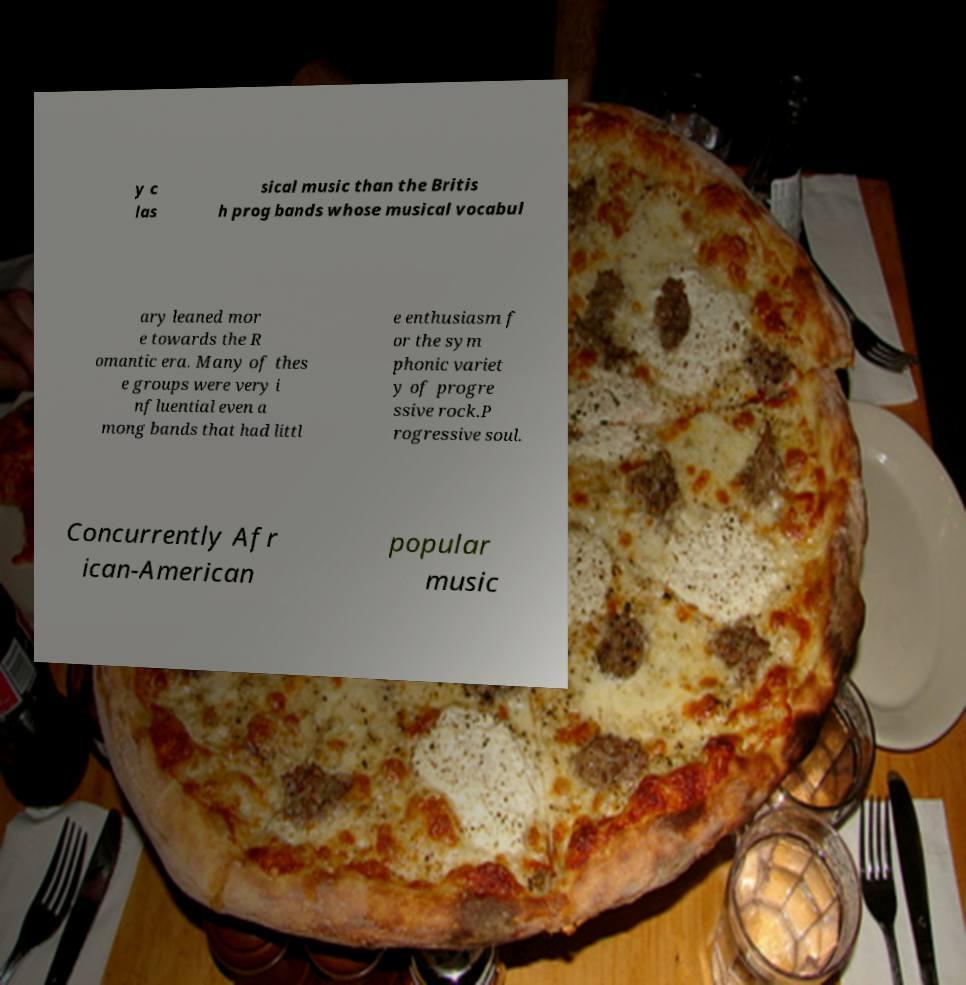Can you accurately transcribe the text from the provided image for me? y c las sical music than the Britis h prog bands whose musical vocabul ary leaned mor e towards the R omantic era. Many of thes e groups were very i nfluential even a mong bands that had littl e enthusiasm f or the sym phonic variet y of progre ssive rock.P rogressive soul. Concurrently Afr ican-American popular music 